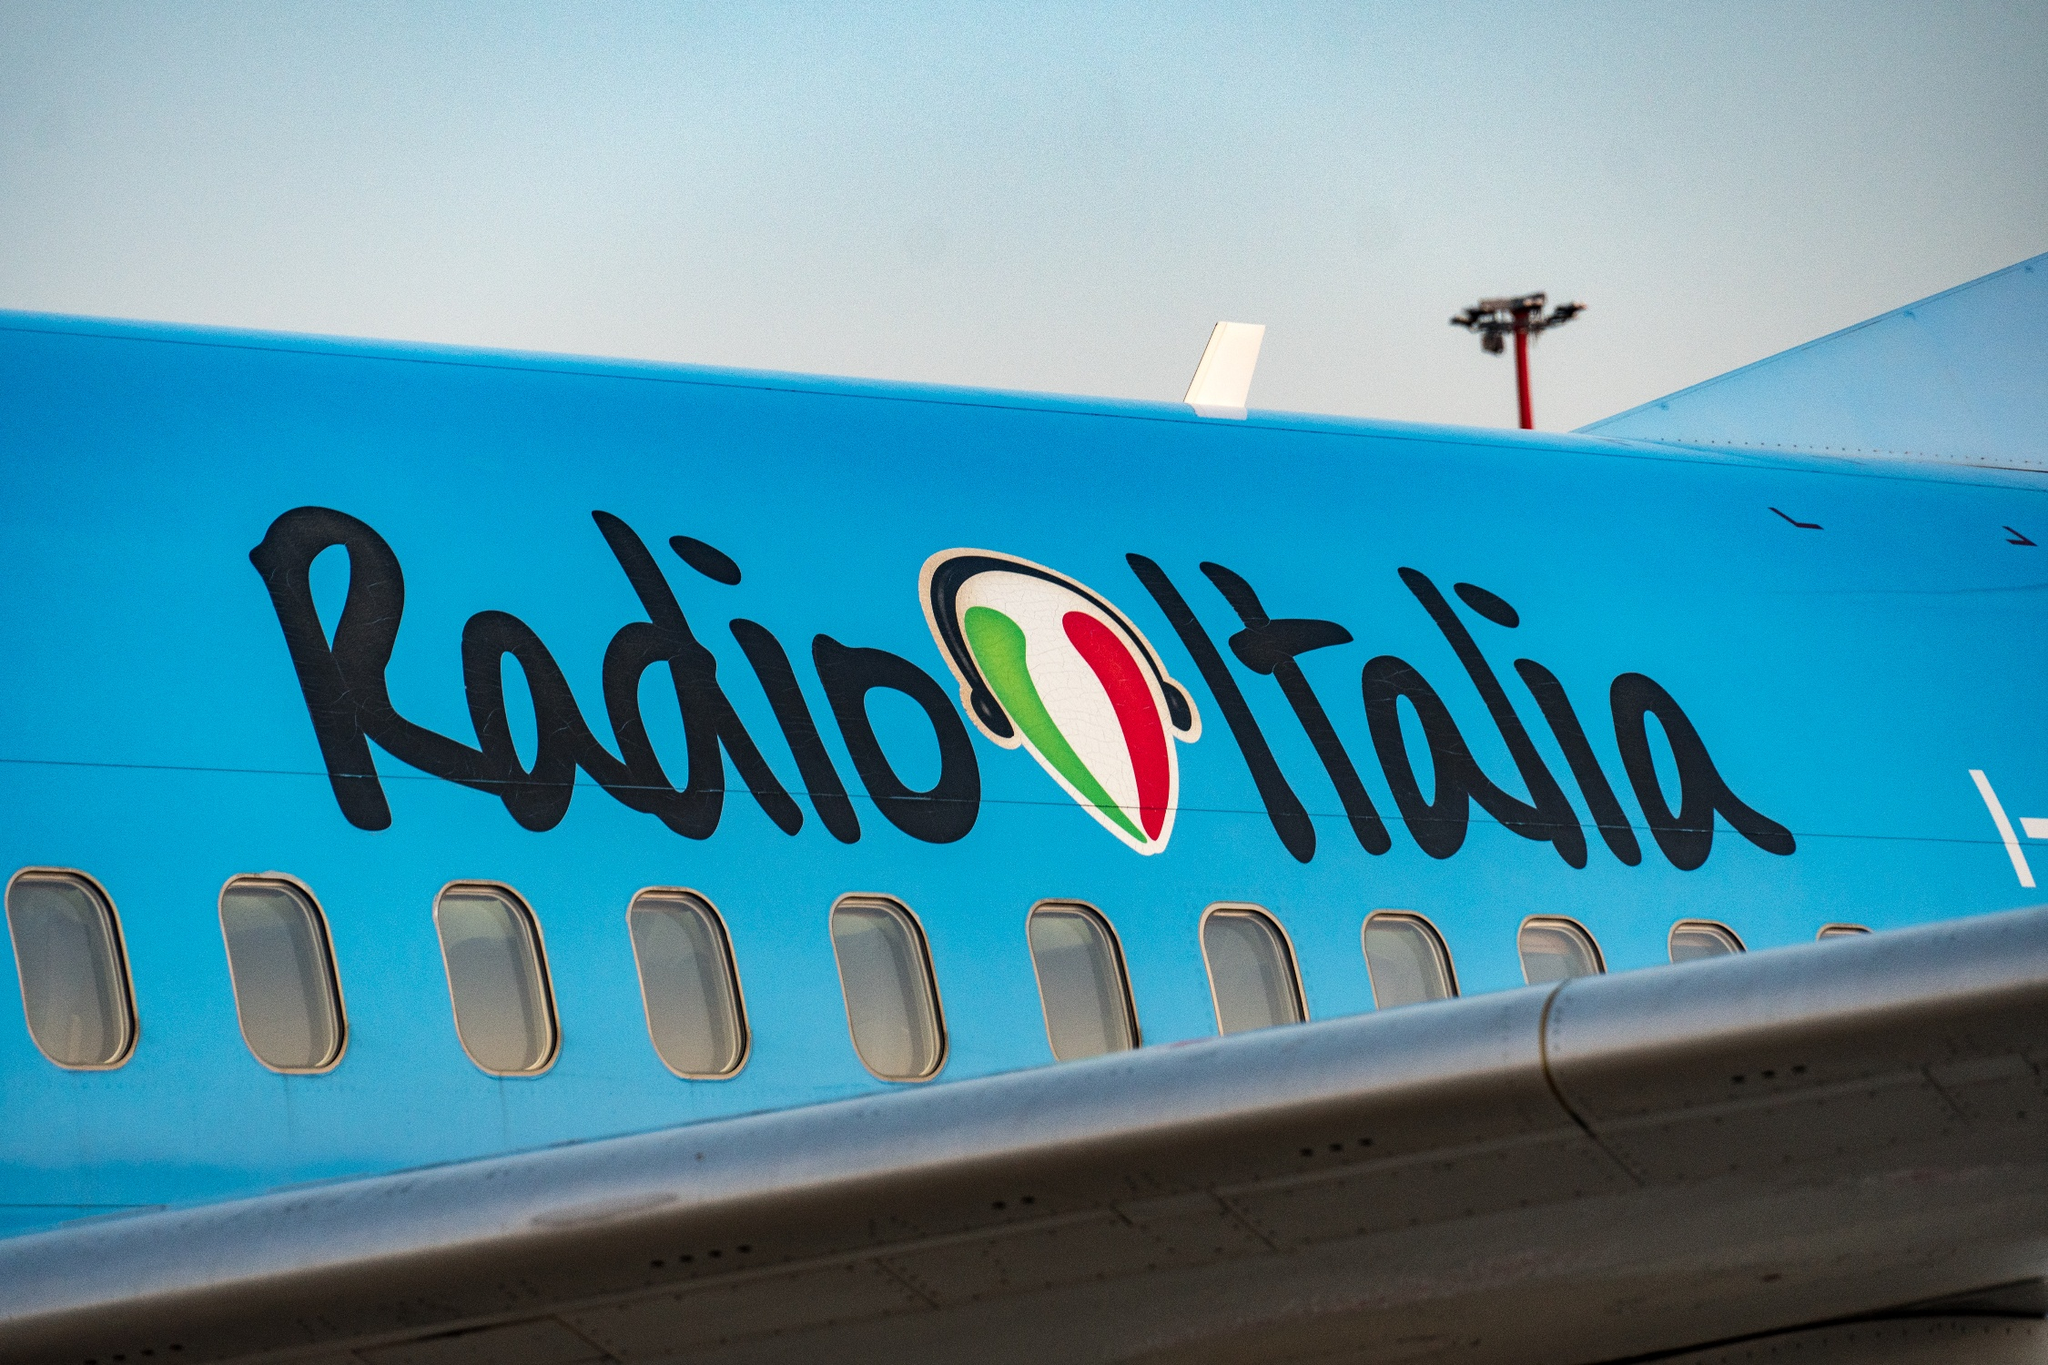What significance might the logo of the Italian flag on the airplane hold? The logo of the Italian flag on the airplane likely symbolizes the national identity and heritage of Italy, suggesting that the aircraft is either operated by an Italian company or is promoting Italian culture and media abroad through entities like Radio Italia. 